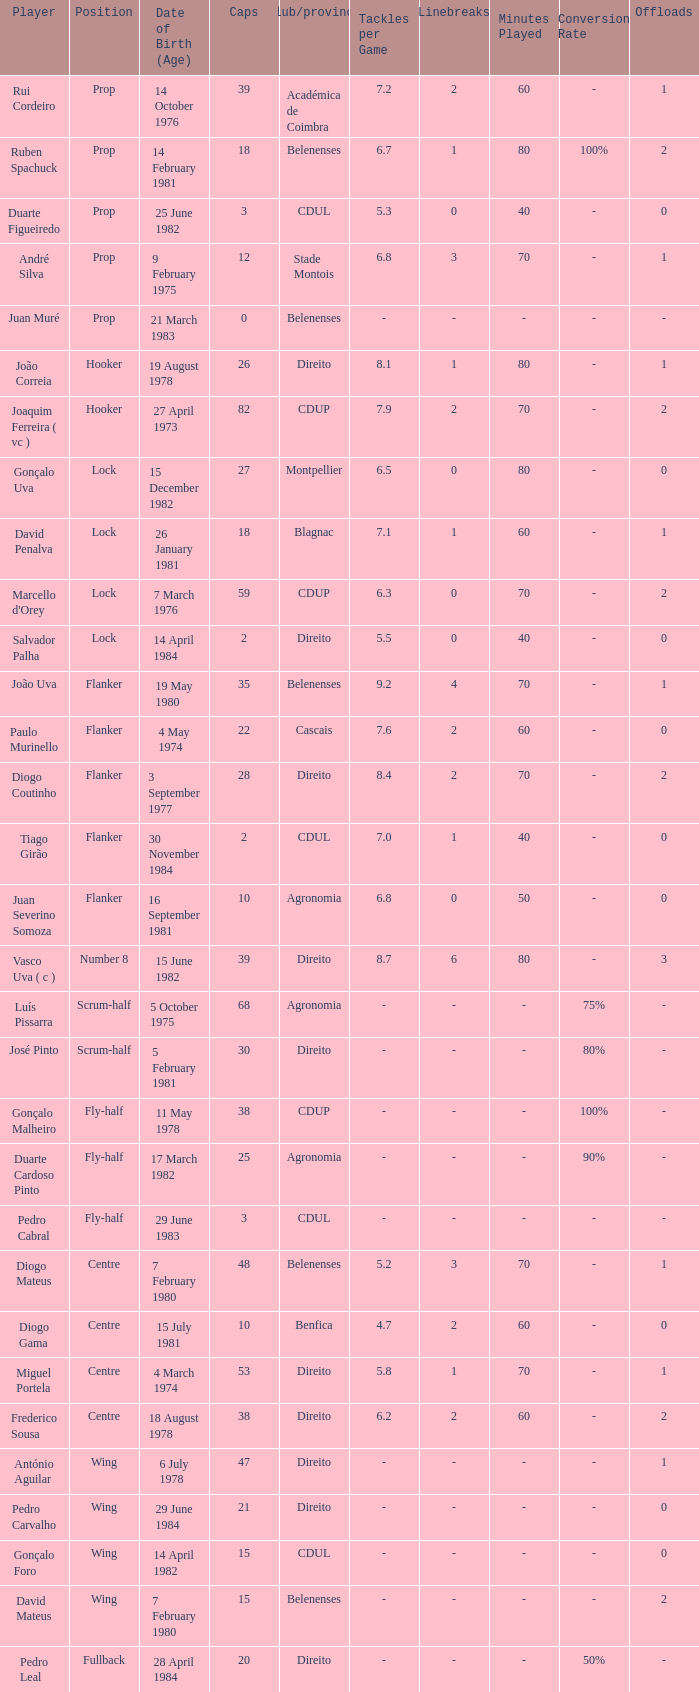Which Club/province has a Player of david penalva? Blagnac. 